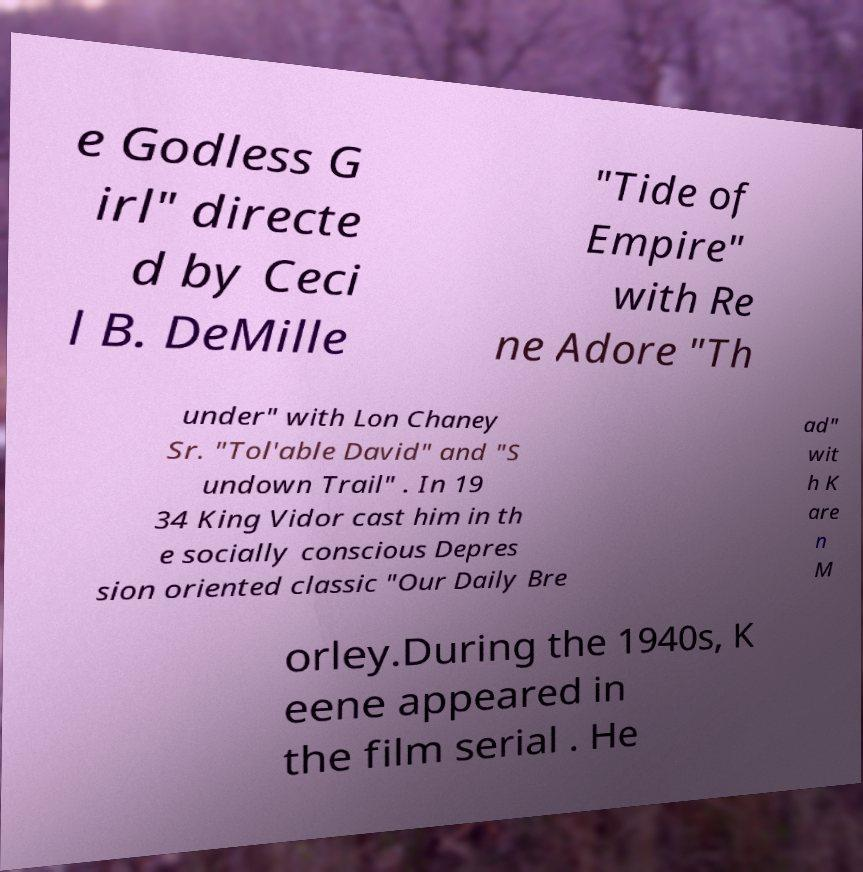Can you read and provide the text displayed in the image?This photo seems to have some interesting text. Can you extract and type it out for me? e Godless G irl" directe d by Ceci l B. DeMille "Tide of Empire" with Re ne Adore "Th under" with Lon Chaney Sr. "Tol'able David" and "S undown Trail" . In 19 34 King Vidor cast him in th e socially conscious Depres sion oriented classic "Our Daily Bre ad" wit h K are n M orley.During the 1940s, K eene appeared in the film serial . He 